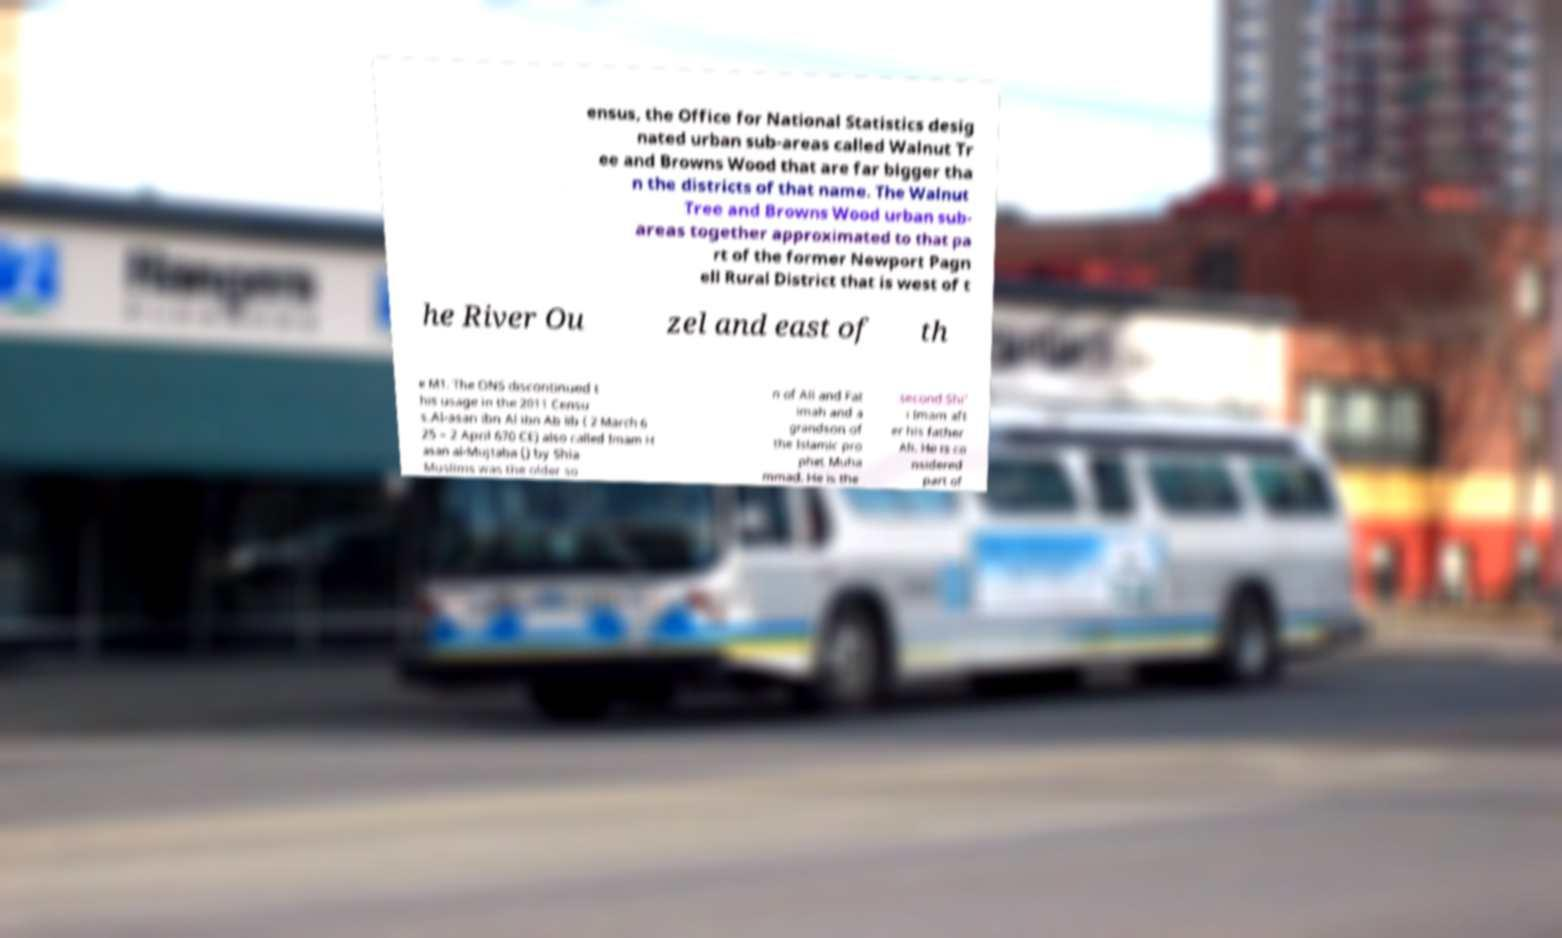Can you read and provide the text displayed in the image?This photo seems to have some interesting text. Can you extract and type it out for me? ensus, the Office for National Statistics desig nated urban sub-areas called Walnut Tr ee and Browns Wood that are far bigger tha n the districts of that name. The Walnut Tree and Browns Wood urban sub- areas together approximated to that pa rt of the former Newport Pagn ell Rural District that is west of t he River Ou zel and east of th e M1. The ONS discontinued t his usage in the 2011 Censu s.Al-asan ibn Al ibn Ab lib ( 2 March 6 25 – 2 April 670 CE) also called Imam H asan al-Mujtaba () by Shia Muslims was the older so n of Ali and Fat imah and a grandson of the Islamic pro phet Muha mmad. He is the second Shi' i Imam aft er his father Ali. He is co nsidered part of 